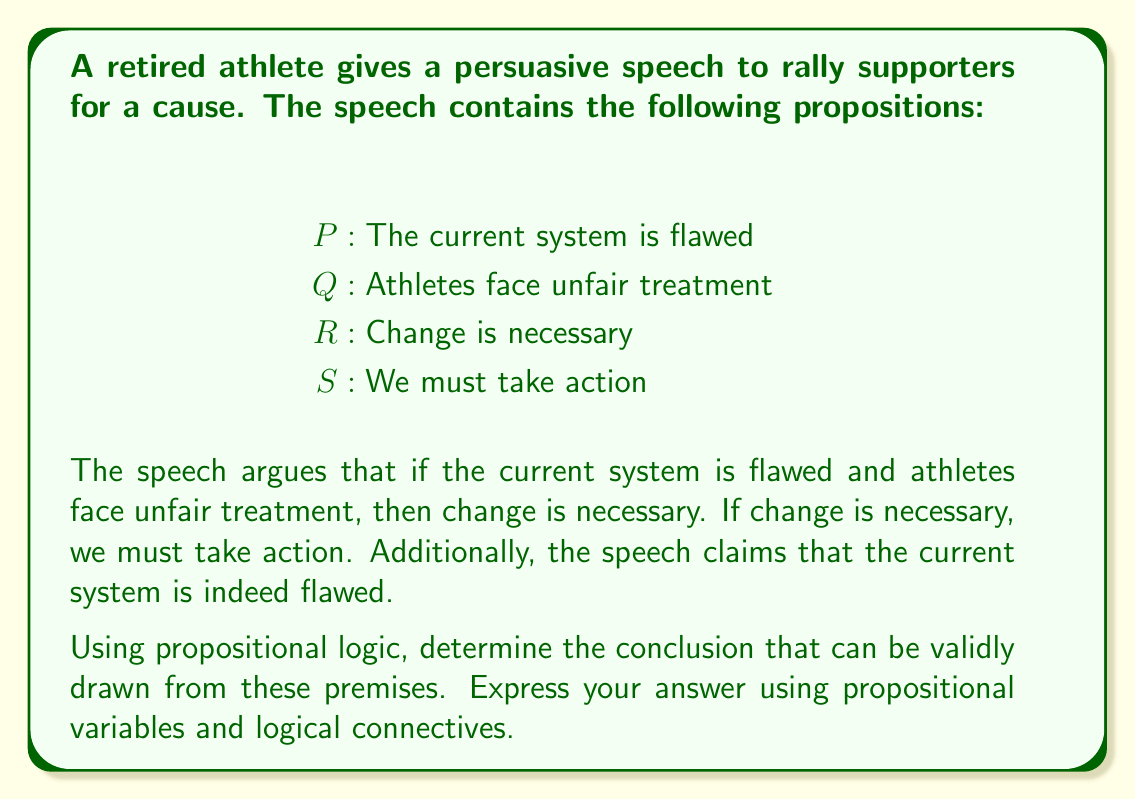Give your solution to this math problem. Let's break down the logical structure of the speech using propositional logic:

1. First premise: $(P \land Q) \rightarrow R$
   This represents "If the current system is flawed and athletes face unfair treatment, then change is necessary."

2. Second premise: $R \rightarrow S$
   This represents "If change is necessary, we must take action."

3. Third premise: $P$
   This represents the claim that "The current system is indeed flawed."

Now, let's apply logical reasoning:

1. We know $P$ is true (given in the third premise).
2. We don't have direct information about $Q$, so we cannot use the first premise yet.
3. However, we can use the law of simplification (or conjunction elimination) to conclude that $P$ is true, which we already knew.

At this point, we cannot make any further deductions because we lack information about $Q$. We cannot conclude $R$ or $S$ with certainty.

The most we can conclude is $P$, which was already given as a premise. In propositional logic, we cannot introduce new information that wasn't provided in the premises or deduce anything beyond what's strictly implied by the given information.
Answer: $P$ 